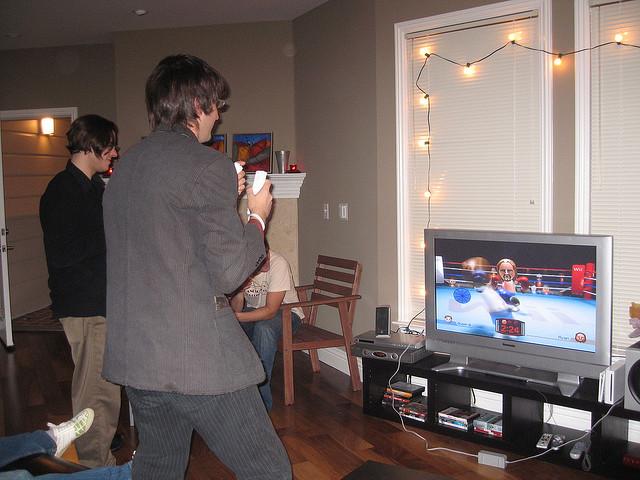What is hanging up in the windows?
Keep it brief. Lights. What is the man is the holding?
Quick response, please. Wii controller. How many people are playing video games?
Answer briefly. 2. How many windows are there?
Quick response, please. 2. What game system are they playing?
Concise answer only. Wii. What color is the stereo?
Answer briefly. Silver. Which item is plaid?
Write a very short answer. None. 